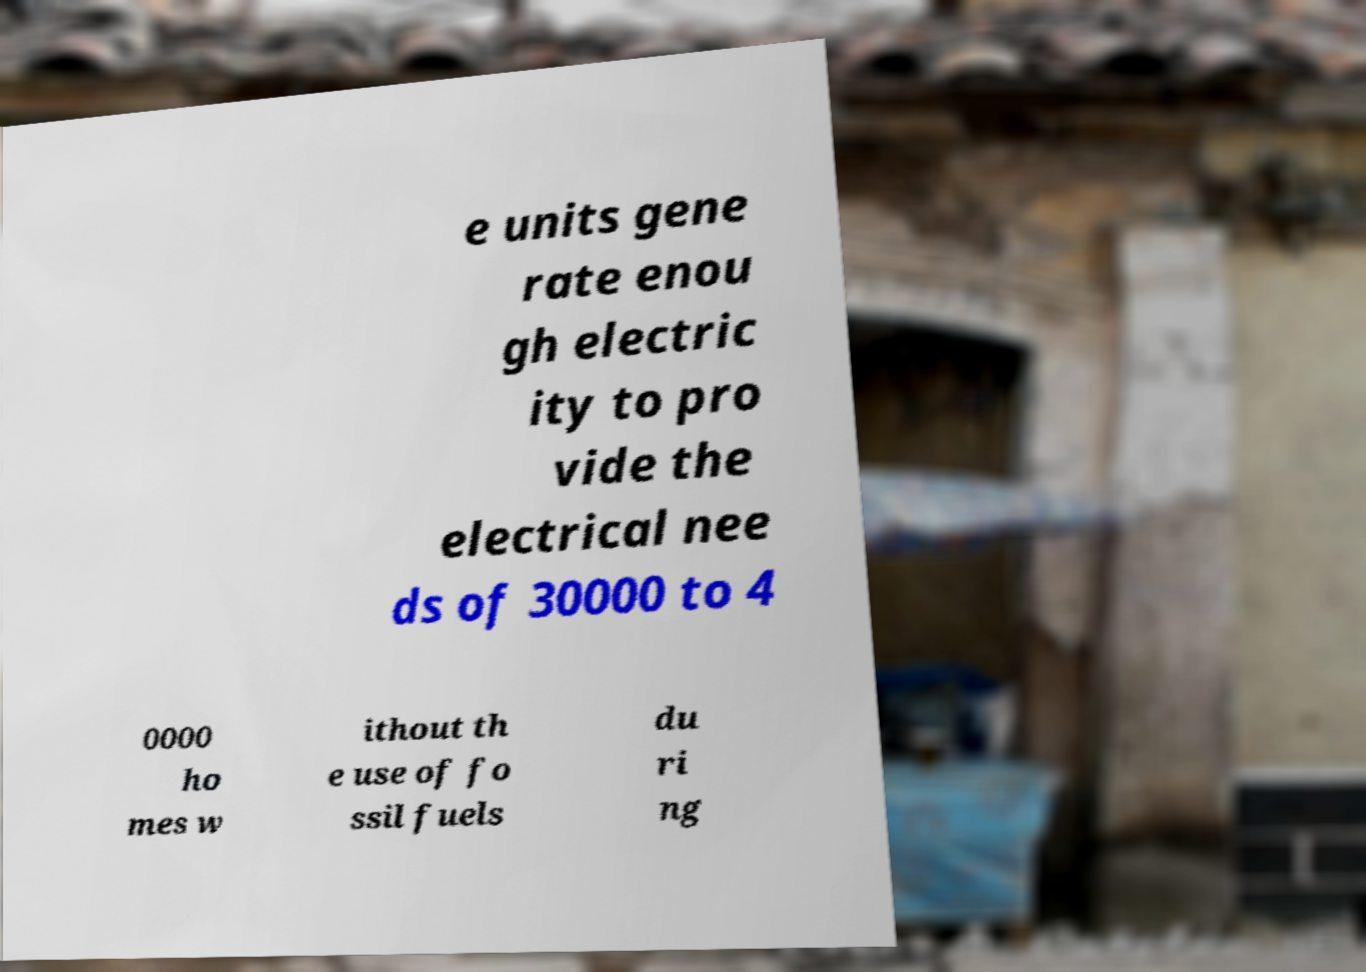Could you extract and type out the text from this image? e units gene rate enou gh electric ity to pro vide the electrical nee ds of 30000 to 4 0000 ho mes w ithout th e use of fo ssil fuels du ri ng 